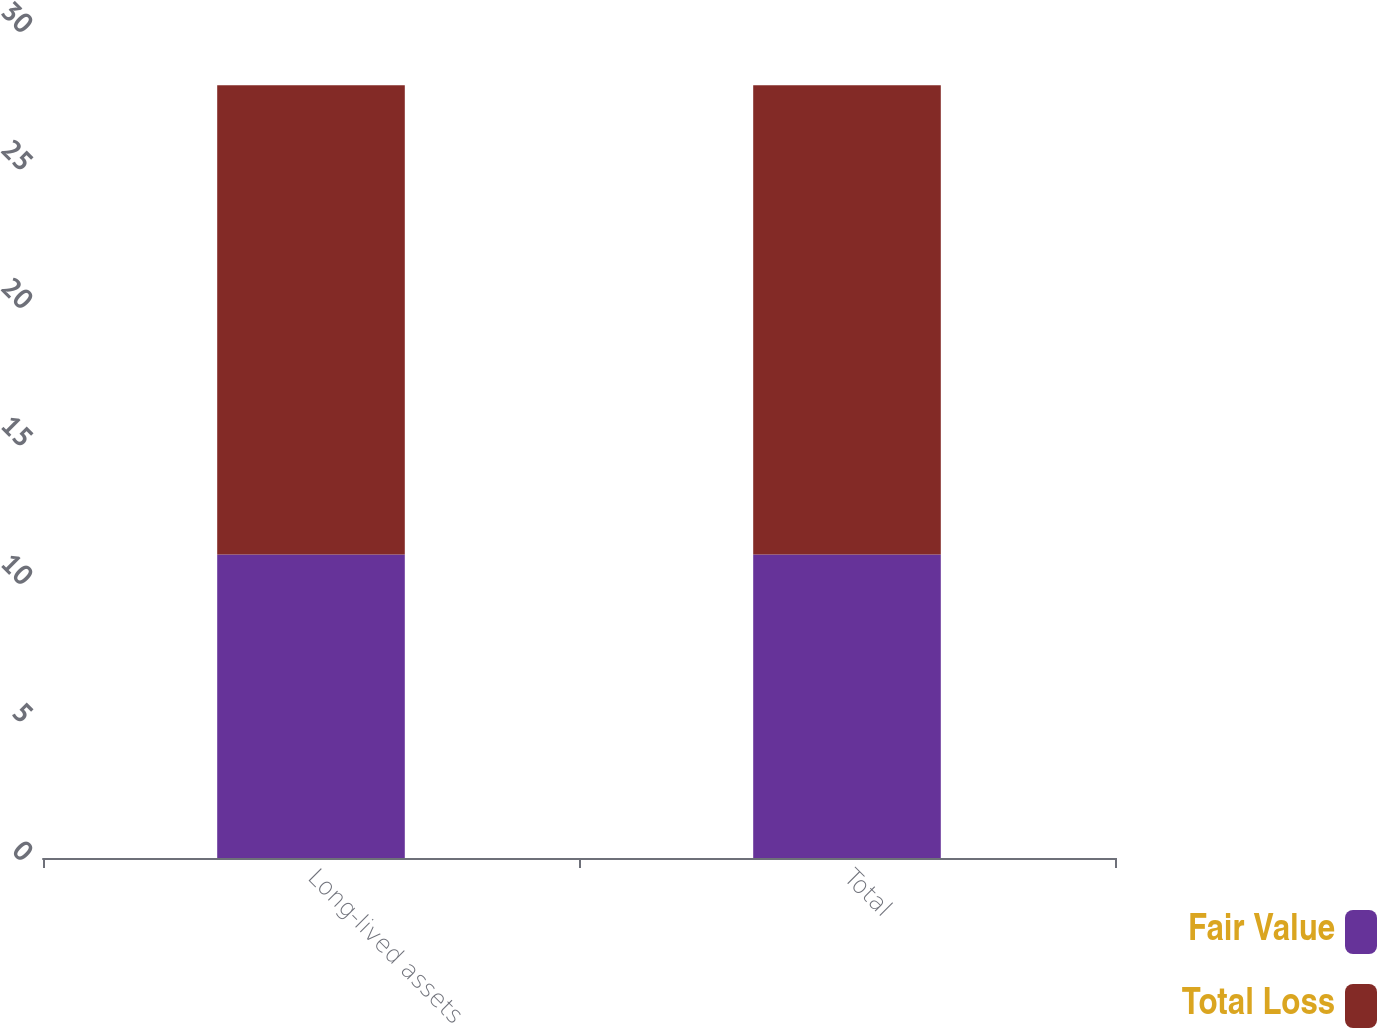Convert chart. <chart><loc_0><loc_0><loc_500><loc_500><stacked_bar_chart><ecel><fcel>Long-lived assets<fcel>Total<nl><fcel>Fair Value<fcel>11<fcel>11<nl><fcel>Total Loss<fcel>17<fcel>17<nl></chart> 